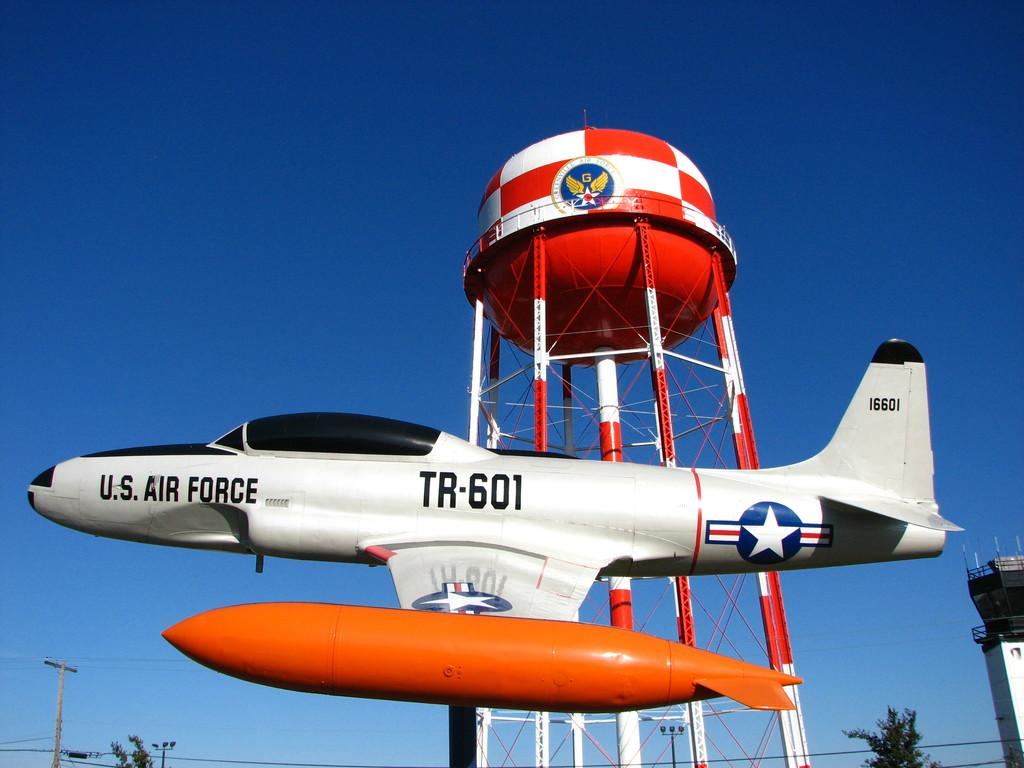What is the main subject of the image? The main subject of the image is an airplane. What can be seen in the background of the image? There is a tower with a tank in the background. What type of vegetation is present in the image? There are trees in the image. What else can be seen in the image besides the airplane and trees? There is a pole with wires and a building on the right side of the image. What is visible in the sky in the image? The sky is visible in the image. What type of copper desk can be seen in the image? There is no copper desk present in the image. What type of prose is being written on the airplane in the image? There is no writing or prose visible on the airplane in the image. 